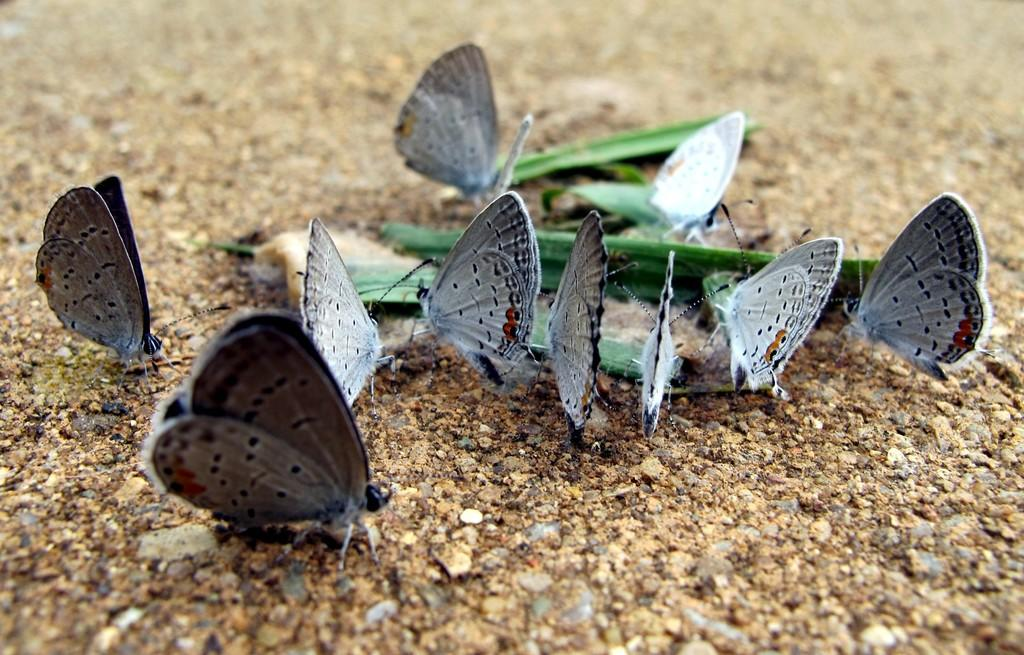Where was the image taken? The image is taken outdoors. What can be seen at the bottom of the image? There is a ground visible at the bottom of the image. What is the main subject of the image? There are many butterflies in the middle of the image. Where are the butterflies located? The butterflies are on the ground. What type of vegetation is present in the image? There is a green leaf in the image. How does the photographer change the bait to attract more butterflies in the image? There is no mention of bait or the photographer changing anything in the image. The butterflies are already present on the ground. 